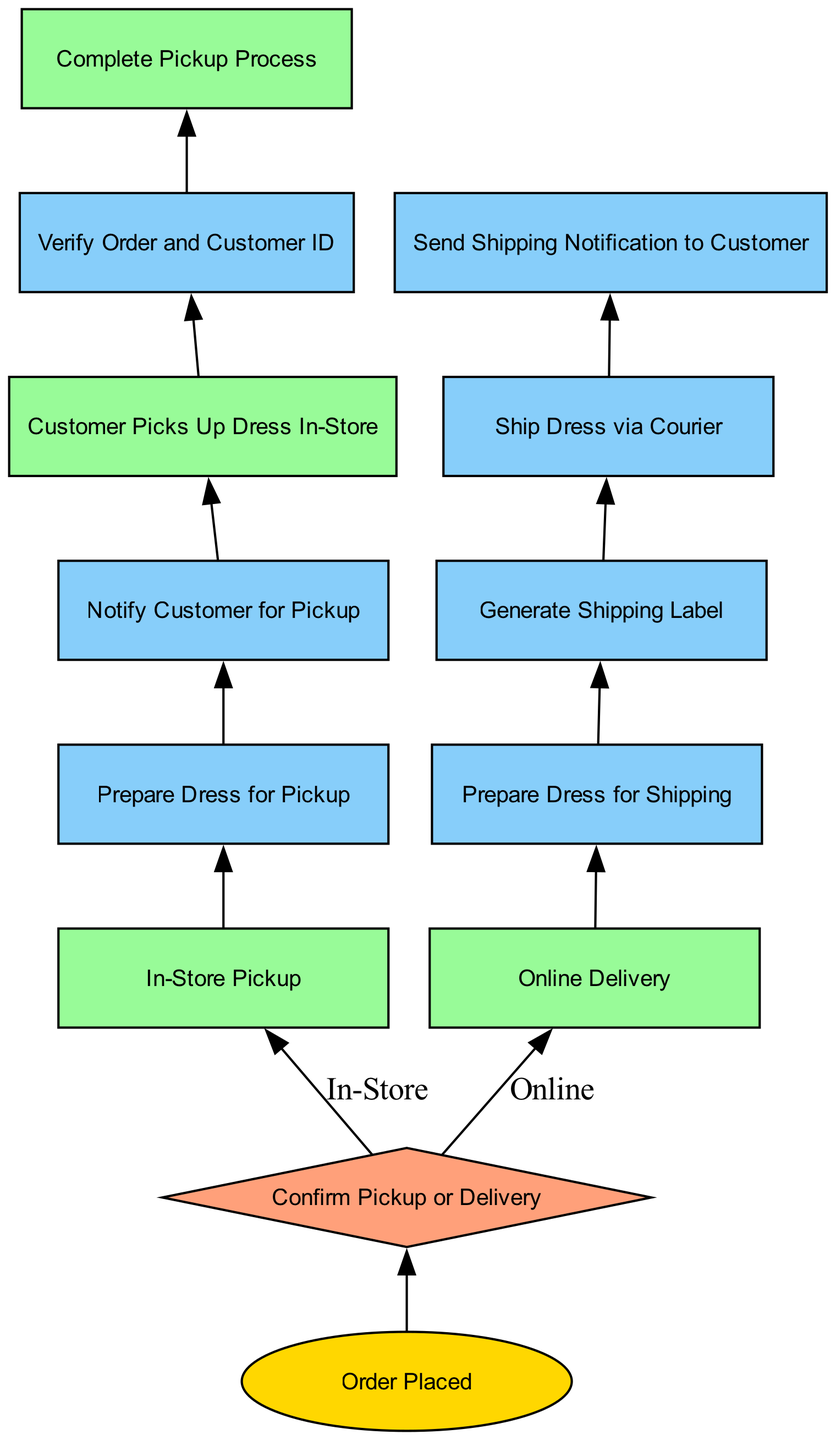What is the starting point of the diagram? The diagram starts with the "Order Placed" element, which indicates that the customer has placed an order online. This is the first node and represents the beginning of the process.
Answer: Order Placed How many nodes are in the diagram? By counting each individual element in the diagram, there are a total of 13 nodes representing different stages and actions in the flowchart.
Answer: 13 What action follows "Prepare Dress for Pickup"? The "Notify Customer for Pickup" action follows right after "Prepare Dress for Pickup", indicating the next step that needs to be taken after the dress is prepared.
Answer: Notify Customer for Pickup What type of node is "Confirm Pickup or Delivery"? The "Confirm Pickup or Delivery" is a decision type node, which suggests that it requires a choice between two options: in-store pickup or online delivery.
Answer: Decision If the customer chooses "Online Delivery", which process occurs next? If "Online Delivery" is selected, the next process that occurs is "Prepare Dress for Shipping". This is directly connected following the decision node.
Answer: Prepare Dress for Shipping List the actions taken after the "In-Store Pickup" process. The actions taken after "In-Store Pickup" are: "Prepare Dress for Pickup", then "Notify Customer for Pickup", followed by "Customer Picks Up Dress In-Store", "Verify Order and Customer ID", and "Complete Pickup Process". These actions create a sequence that ensures proper handling of in-store orders.
Answer: Prepare Dress for Pickup, Notify Customer for Pickup, Customer Picks Up Dress In-Store, Verify Order and Customer ID, Complete Pickup Process What does the "Generate Shipping Label" action entail? The "Generate Shipping Label" action involves printing a shipping label that contains the customer's address, which is crucial for shipping the dress to the correct destination. This step is critical in the online delivery process.
Answer: Print shipping label with customer address What happens after "Ship Dress via Courier"? After "Ship Dress via Courier", the subsequent step is "Send Shipping Notification to Customer", which involves notifying the customer about the shipment status and providing tracking information.
Answer: Send Shipping Notification to Customer What color represents "Process" type nodes in the diagram? The color representing "Process" type nodes in the diagram is light green, specifically the hex code #98FB98, which is used to visually distinguish these types of nodes from others in the flowchart.
Answer: Light green 